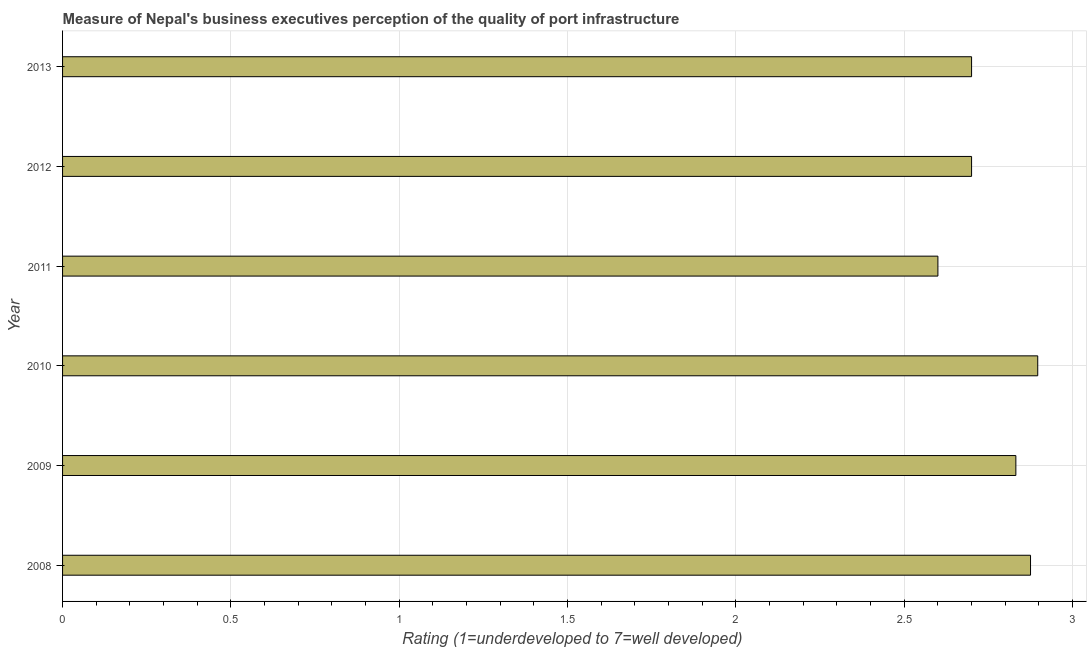Does the graph contain any zero values?
Offer a very short reply. No. Does the graph contain grids?
Provide a short and direct response. Yes. What is the title of the graph?
Offer a terse response. Measure of Nepal's business executives perception of the quality of port infrastructure. What is the label or title of the X-axis?
Your answer should be very brief. Rating (1=underdeveloped to 7=well developed) . What is the label or title of the Y-axis?
Offer a terse response. Year. What is the rating measuring quality of port infrastructure in 2010?
Your answer should be compact. 2.9. Across all years, what is the maximum rating measuring quality of port infrastructure?
Provide a short and direct response. 2.9. In which year was the rating measuring quality of port infrastructure maximum?
Your answer should be compact. 2010. In which year was the rating measuring quality of port infrastructure minimum?
Offer a very short reply. 2011. What is the sum of the rating measuring quality of port infrastructure?
Keep it short and to the point. 16.6. What is the difference between the rating measuring quality of port infrastructure in 2009 and 2011?
Your answer should be very brief. 0.23. What is the average rating measuring quality of port infrastructure per year?
Offer a very short reply. 2.77. What is the median rating measuring quality of port infrastructure?
Provide a short and direct response. 2.77. In how many years, is the rating measuring quality of port infrastructure greater than 1.2 ?
Your response must be concise. 6. What is the ratio of the rating measuring quality of port infrastructure in 2008 to that in 2013?
Provide a short and direct response. 1.06. Is the rating measuring quality of port infrastructure in 2009 less than that in 2013?
Give a very brief answer. No. Is the difference between the rating measuring quality of port infrastructure in 2008 and 2010 greater than the difference between any two years?
Give a very brief answer. No. What is the difference between the highest and the second highest rating measuring quality of port infrastructure?
Your response must be concise. 0.02. What is the difference between the highest and the lowest rating measuring quality of port infrastructure?
Keep it short and to the point. 0.3. How many bars are there?
Your answer should be compact. 6. What is the difference between two consecutive major ticks on the X-axis?
Make the answer very short. 0.5. Are the values on the major ticks of X-axis written in scientific E-notation?
Ensure brevity in your answer.  No. What is the Rating (1=underdeveloped to 7=well developed)  in 2008?
Your answer should be compact. 2.88. What is the Rating (1=underdeveloped to 7=well developed)  of 2009?
Provide a short and direct response. 2.83. What is the Rating (1=underdeveloped to 7=well developed)  of 2010?
Offer a very short reply. 2.9. What is the Rating (1=underdeveloped to 7=well developed)  in 2012?
Your answer should be compact. 2.7. What is the difference between the Rating (1=underdeveloped to 7=well developed)  in 2008 and 2009?
Keep it short and to the point. 0.04. What is the difference between the Rating (1=underdeveloped to 7=well developed)  in 2008 and 2010?
Make the answer very short. -0.02. What is the difference between the Rating (1=underdeveloped to 7=well developed)  in 2008 and 2011?
Keep it short and to the point. 0.28. What is the difference between the Rating (1=underdeveloped to 7=well developed)  in 2008 and 2012?
Keep it short and to the point. 0.18. What is the difference between the Rating (1=underdeveloped to 7=well developed)  in 2008 and 2013?
Offer a terse response. 0.18. What is the difference between the Rating (1=underdeveloped to 7=well developed)  in 2009 and 2010?
Give a very brief answer. -0.06. What is the difference between the Rating (1=underdeveloped to 7=well developed)  in 2009 and 2011?
Your response must be concise. 0.23. What is the difference between the Rating (1=underdeveloped to 7=well developed)  in 2009 and 2012?
Ensure brevity in your answer.  0.13. What is the difference between the Rating (1=underdeveloped to 7=well developed)  in 2009 and 2013?
Your answer should be compact. 0.13. What is the difference between the Rating (1=underdeveloped to 7=well developed)  in 2010 and 2011?
Give a very brief answer. 0.3. What is the difference between the Rating (1=underdeveloped to 7=well developed)  in 2010 and 2012?
Ensure brevity in your answer.  0.2. What is the difference between the Rating (1=underdeveloped to 7=well developed)  in 2010 and 2013?
Your answer should be compact. 0.2. What is the difference between the Rating (1=underdeveloped to 7=well developed)  in 2011 and 2013?
Keep it short and to the point. -0.1. What is the difference between the Rating (1=underdeveloped to 7=well developed)  in 2012 and 2013?
Offer a terse response. 0. What is the ratio of the Rating (1=underdeveloped to 7=well developed)  in 2008 to that in 2009?
Your response must be concise. 1.01. What is the ratio of the Rating (1=underdeveloped to 7=well developed)  in 2008 to that in 2011?
Make the answer very short. 1.11. What is the ratio of the Rating (1=underdeveloped to 7=well developed)  in 2008 to that in 2012?
Provide a succinct answer. 1.06. What is the ratio of the Rating (1=underdeveloped to 7=well developed)  in 2008 to that in 2013?
Your answer should be very brief. 1.06. What is the ratio of the Rating (1=underdeveloped to 7=well developed)  in 2009 to that in 2010?
Make the answer very short. 0.98. What is the ratio of the Rating (1=underdeveloped to 7=well developed)  in 2009 to that in 2011?
Provide a succinct answer. 1.09. What is the ratio of the Rating (1=underdeveloped to 7=well developed)  in 2009 to that in 2012?
Your answer should be very brief. 1.05. What is the ratio of the Rating (1=underdeveloped to 7=well developed)  in 2009 to that in 2013?
Provide a short and direct response. 1.05. What is the ratio of the Rating (1=underdeveloped to 7=well developed)  in 2010 to that in 2011?
Offer a very short reply. 1.11. What is the ratio of the Rating (1=underdeveloped to 7=well developed)  in 2010 to that in 2012?
Keep it short and to the point. 1.07. What is the ratio of the Rating (1=underdeveloped to 7=well developed)  in 2010 to that in 2013?
Keep it short and to the point. 1.07. What is the ratio of the Rating (1=underdeveloped to 7=well developed)  in 2011 to that in 2012?
Ensure brevity in your answer.  0.96. 